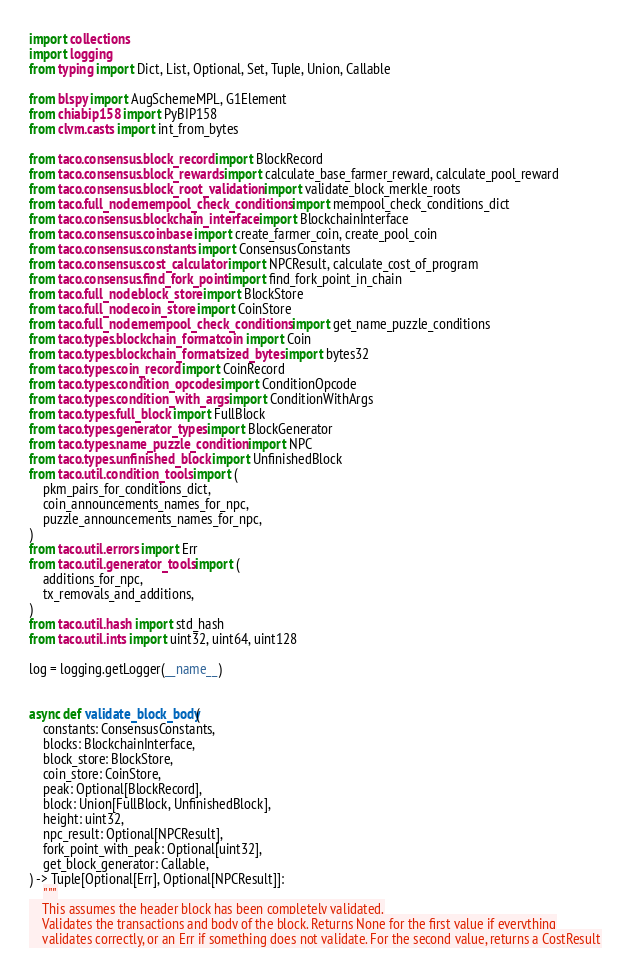Convert code to text. <code><loc_0><loc_0><loc_500><loc_500><_Python_>import collections
import logging
from typing import Dict, List, Optional, Set, Tuple, Union, Callable

from blspy import AugSchemeMPL, G1Element
from chiabip158 import PyBIP158
from clvm.casts import int_from_bytes

from taco.consensus.block_record import BlockRecord
from taco.consensus.block_rewards import calculate_base_farmer_reward, calculate_pool_reward
from taco.consensus.block_root_validation import validate_block_merkle_roots
from taco.full_node.mempool_check_conditions import mempool_check_conditions_dict
from taco.consensus.blockchain_interface import BlockchainInterface
from taco.consensus.coinbase import create_farmer_coin, create_pool_coin
from taco.consensus.constants import ConsensusConstants
from taco.consensus.cost_calculator import NPCResult, calculate_cost_of_program
from taco.consensus.find_fork_point import find_fork_point_in_chain
from taco.full_node.block_store import BlockStore
from taco.full_node.coin_store import CoinStore
from taco.full_node.mempool_check_conditions import get_name_puzzle_conditions
from taco.types.blockchain_format.coin import Coin
from taco.types.blockchain_format.sized_bytes import bytes32
from taco.types.coin_record import CoinRecord
from taco.types.condition_opcodes import ConditionOpcode
from taco.types.condition_with_args import ConditionWithArgs
from taco.types.full_block import FullBlock
from taco.types.generator_types import BlockGenerator
from taco.types.name_puzzle_condition import NPC
from taco.types.unfinished_block import UnfinishedBlock
from taco.util.condition_tools import (
    pkm_pairs_for_conditions_dict,
    coin_announcements_names_for_npc,
    puzzle_announcements_names_for_npc,
)
from taco.util.errors import Err
from taco.util.generator_tools import (
    additions_for_npc,
    tx_removals_and_additions,
)
from taco.util.hash import std_hash
from taco.util.ints import uint32, uint64, uint128

log = logging.getLogger(__name__)


async def validate_block_body(
    constants: ConsensusConstants,
    blocks: BlockchainInterface,
    block_store: BlockStore,
    coin_store: CoinStore,
    peak: Optional[BlockRecord],
    block: Union[FullBlock, UnfinishedBlock],
    height: uint32,
    npc_result: Optional[NPCResult],
    fork_point_with_peak: Optional[uint32],
    get_block_generator: Callable,
) -> Tuple[Optional[Err], Optional[NPCResult]]:
    """
    This assumes the header block has been completely validated.
    Validates the transactions and body of the block. Returns None for the first value if everything
    validates correctly, or an Err if something does not validate. For the second value, returns a CostResult</code> 